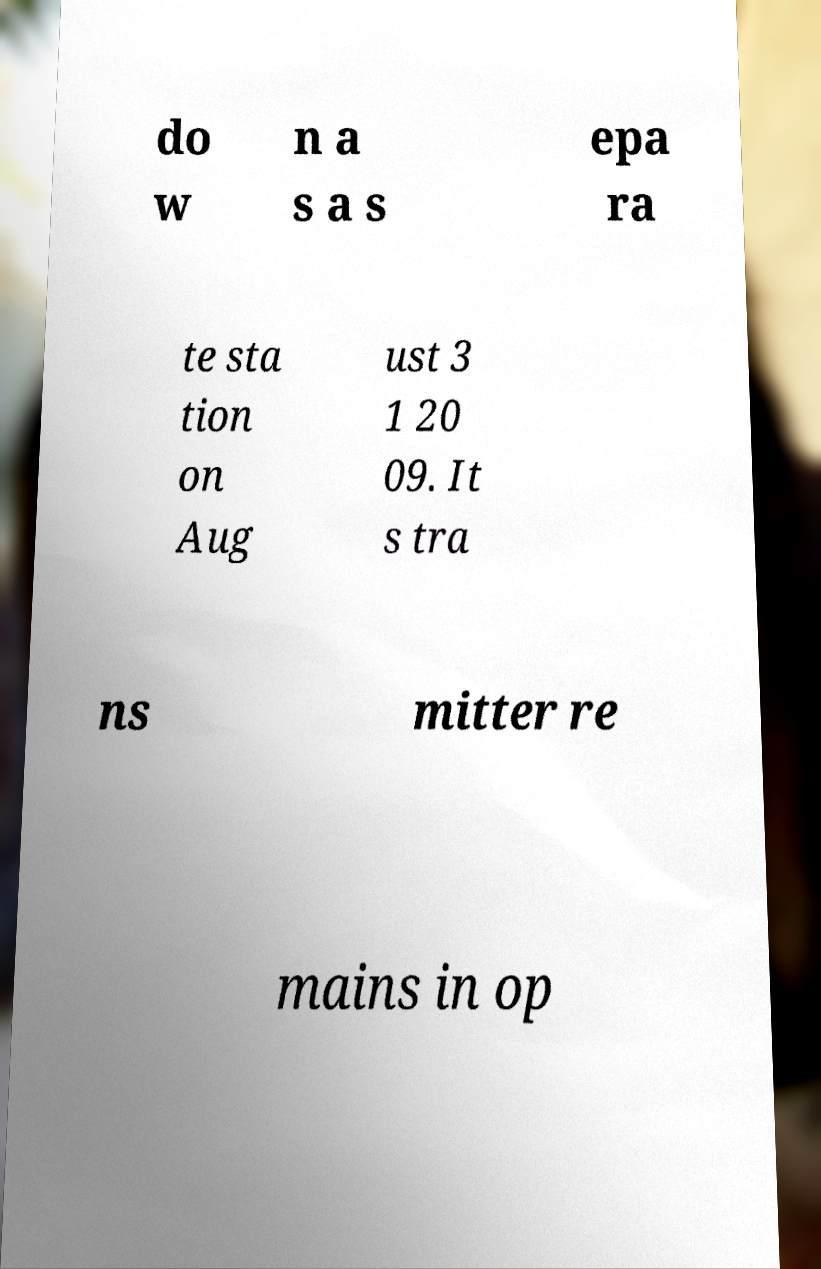Can you accurately transcribe the text from the provided image for me? do w n a s a s epa ra te sta tion on Aug ust 3 1 20 09. It s tra ns mitter re mains in op 